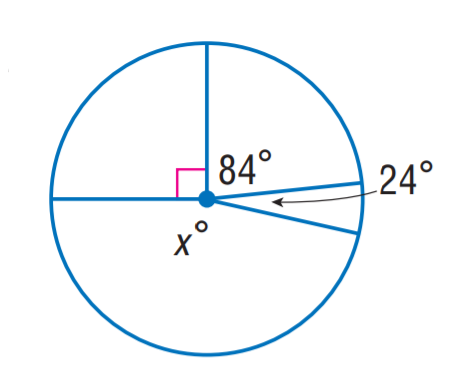Question: Find x.
Choices:
A. 96
B. 156
C. 162
D. 174
Answer with the letter. Answer: C 